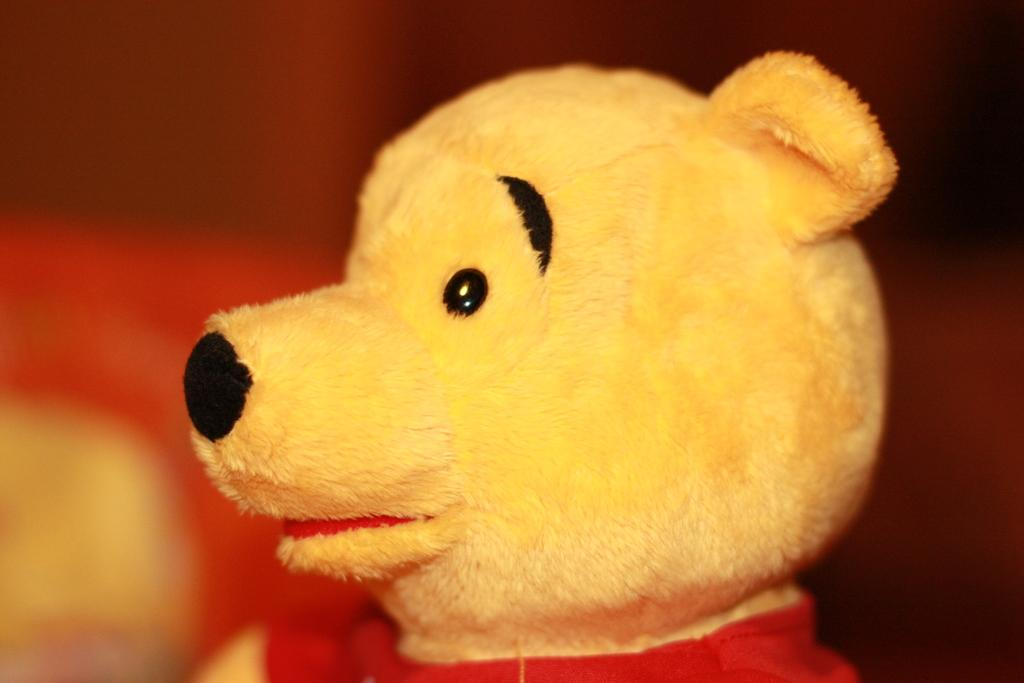What type of toy is in the picture? There is a teddy bear doll in the picture. What part of the teddy bear is visible in the image? The teddy bear has a head in the image. What color is the teddy bear's T-shirt? The teddy bear's T-shirt is red in color. How much honey is the teddy bear holding in the image? There is no honey present in the image; the teddy bear is not holding anything. 